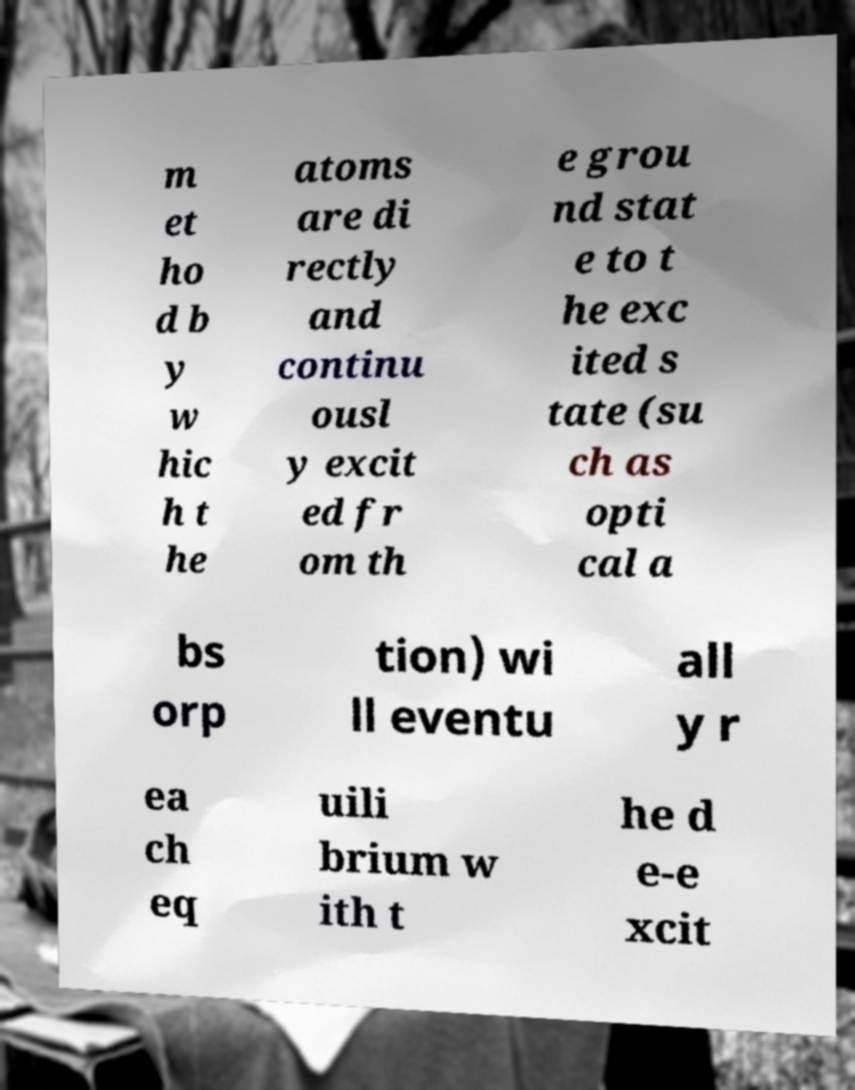Could you extract and type out the text from this image? m et ho d b y w hic h t he atoms are di rectly and continu ousl y excit ed fr om th e grou nd stat e to t he exc ited s tate (su ch as opti cal a bs orp tion) wi ll eventu all y r ea ch eq uili brium w ith t he d e-e xcit 